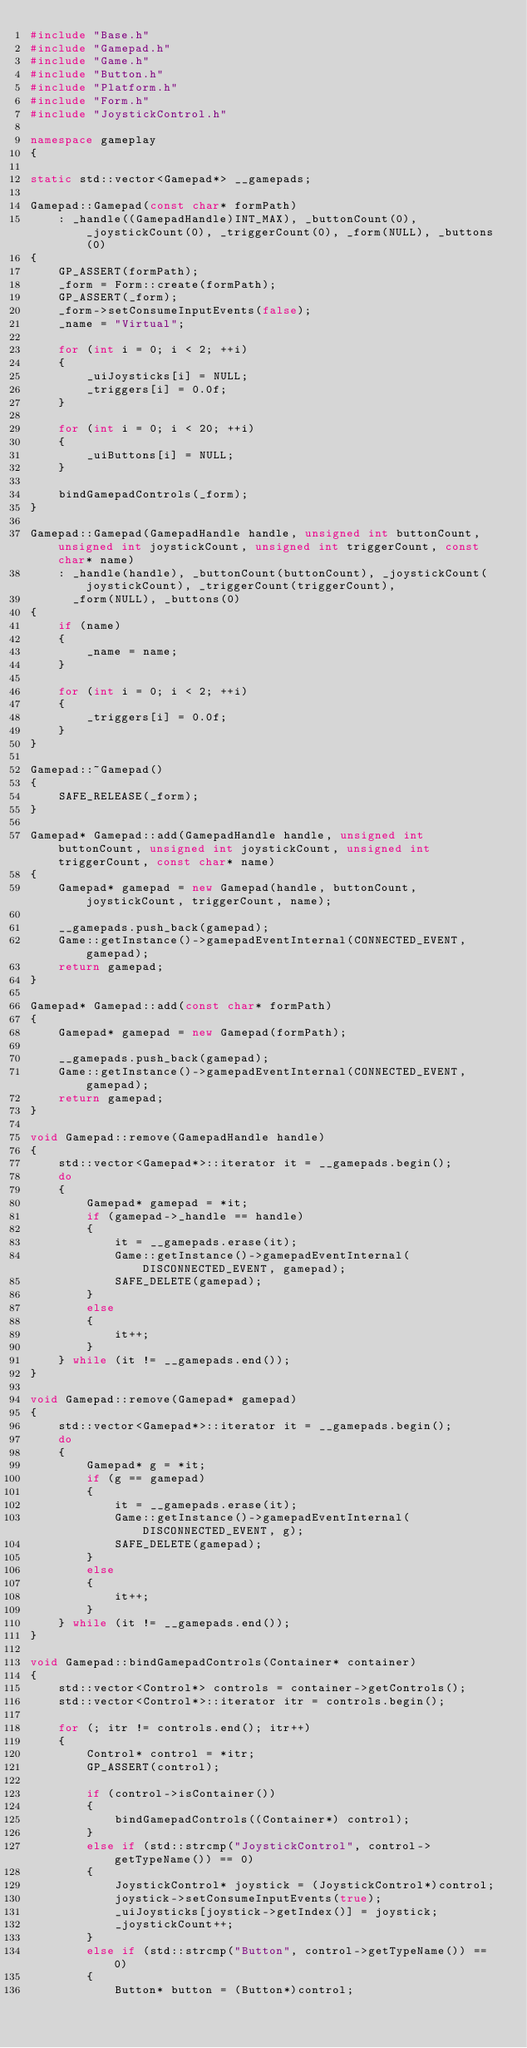Convert code to text. <code><loc_0><loc_0><loc_500><loc_500><_C++_>#include "Base.h"
#include "Gamepad.h"
#include "Game.h"
#include "Button.h"
#include "Platform.h"
#include "Form.h"
#include "JoystickControl.h"

namespace gameplay
{

static std::vector<Gamepad*> __gamepads;

Gamepad::Gamepad(const char* formPath)
    : _handle((GamepadHandle)INT_MAX), _buttonCount(0), _joystickCount(0), _triggerCount(0), _form(NULL), _buttons(0)
{
    GP_ASSERT(formPath);
    _form = Form::create(formPath);
    GP_ASSERT(_form);
    _form->setConsumeInputEvents(false);
    _name = "Virtual";

    for (int i = 0; i < 2; ++i)
    {
        _uiJoysticks[i] = NULL;
        _triggers[i] = 0.0f;
    }

    for (int i = 0; i < 20; ++i)
    {
        _uiButtons[i] = NULL;
    }

    bindGamepadControls(_form);
}

Gamepad::Gamepad(GamepadHandle handle, unsigned int buttonCount, unsigned int joystickCount, unsigned int triggerCount, const char* name)
    : _handle(handle), _buttonCount(buttonCount), _joystickCount(joystickCount), _triggerCount(triggerCount),
      _form(NULL), _buttons(0)
{
    if (name)
    {
        _name = name;
    }

    for (int i = 0; i < 2; ++i)
    {
        _triggers[i] = 0.0f;
    }
}

Gamepad::~Gamepad()
{
    SAFE_RELEASE(_form);
}

Gamepad* Gamepad::add(GamepadHandle handle, unsigned int buttonCount, unsigned int joystickCount, unsigned int triggerCount, const char* name)
{
    Gamepad* gamepad = new Gamepad(handle, buttonCount, joystickCount, triggerCount, name);

    __gamepads.push_back(gamepad);
    Game::getInstance()->gamepadEventInternal(CONNECTED_EVENT, gamepad);
    return gamepad;
}

Gamepad* Gamepad::add(const char* formPath)
{
    Gamepad* gamepad = new Gamepad(formPath);

    __gamepads.push_back(gamepad);
    Game::getInstance()->gamepadEventInternal(CONNECTED_EVENT, gamepad);
    return gamepad;
}

void Gamepad::remove(GamepadHandle handle)
{
    std::vector<Gamepad*>::iterator it = __gamepads.begin();
    do
    {
        Gamepad* gamepad = *it;
        if (gamepad->_handle == handle)
        {
            it = __gamepads.erase(it);
            Game::getInstance()->gamepadEventInternal(DISCONNECTED_EVENT, gamepad);
            SAFE_DELETE(gamepad);
        }
        else
        {
        	it++;
        }
    } while (it != __gamepads.end());
}

void Gamepad::remove(Gamepad* gamepad)
{
    std::vector<Gamepad*>::iterator it = __gamepads.begin();
    do
    {
        Gamepad* g = *it;
        if (g == gamepad)
        {
            it = __gamepads.erase(it);
            Game::getInstance()->gamepadEventInternal(DISCONNECTED_EVENT, g);
            SAFE_DELETE(gamepad);
        }
        else
        {
        	it++;
        }
    } while (it != __gamepads.end());
}

void Gamepad::bindGamepadControls(Container* container)
{
    std::vector<Control*> controls = container->getControls();
    std::vector<Control*>::iterator itr = controls.begin();

    for (; itr != controls.end(); itr++)
    {
        Control* control = *itr;
        GP_ASSERT(control);

        if (control->isContainer())
        {
            bindGamepadControls((Container*) control);
        }
        else if (std::strcmp("JoystickControl", control->getTypeName()) == 0)
        {
            JoystickControl* joystick = (JoystickControl*)control;
            joystick->setConsumeInputEvents(true);
            _uiJoysticks[joystick->getIndex()] = joystick;
            _joystickCount++;
        }
        else if (std::strcmp("Button", control->getTypeName()) == 0)
        {
            Button* button = (Button*)control;</code> 